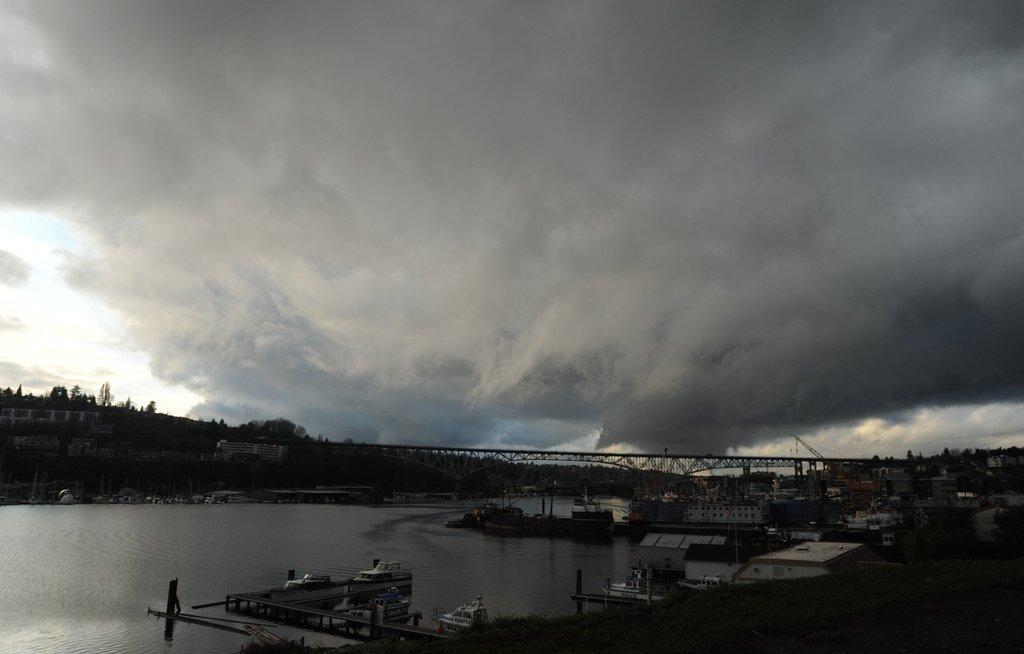How would you summarize this image in a sentence or two? This image consists of fleets of boats in the water, grass, plants, trees, buildings, houses, bridge, metal rods, group of people, fence and the sky. This image is taken may be during night. 